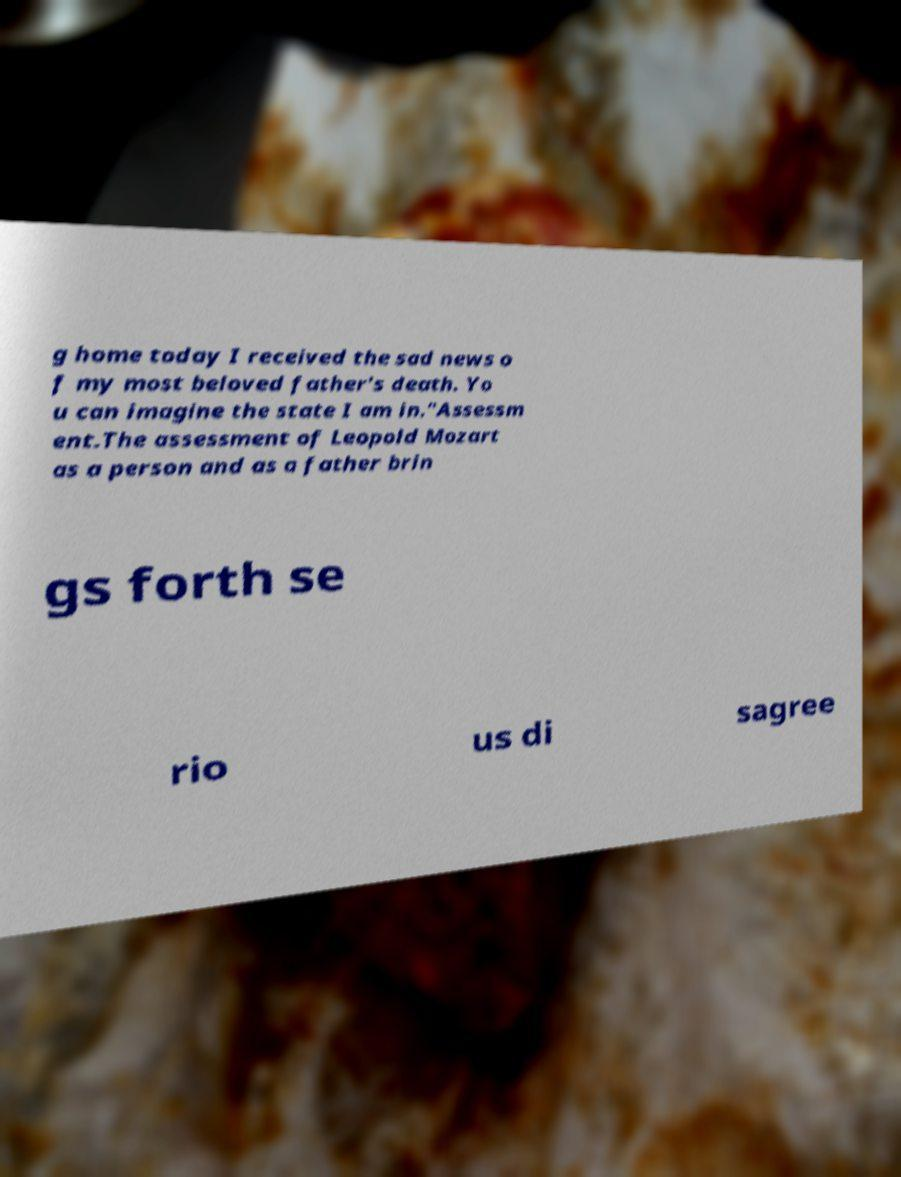Please identify and transcribe the text found in this image. g home today I received the sad news o f my most beloved father's death. Yo u can imagine the state I am in."Assessm ent.The assessment of Leopold Mozart as a person and as a father brin gs forth se rio us di sagree 